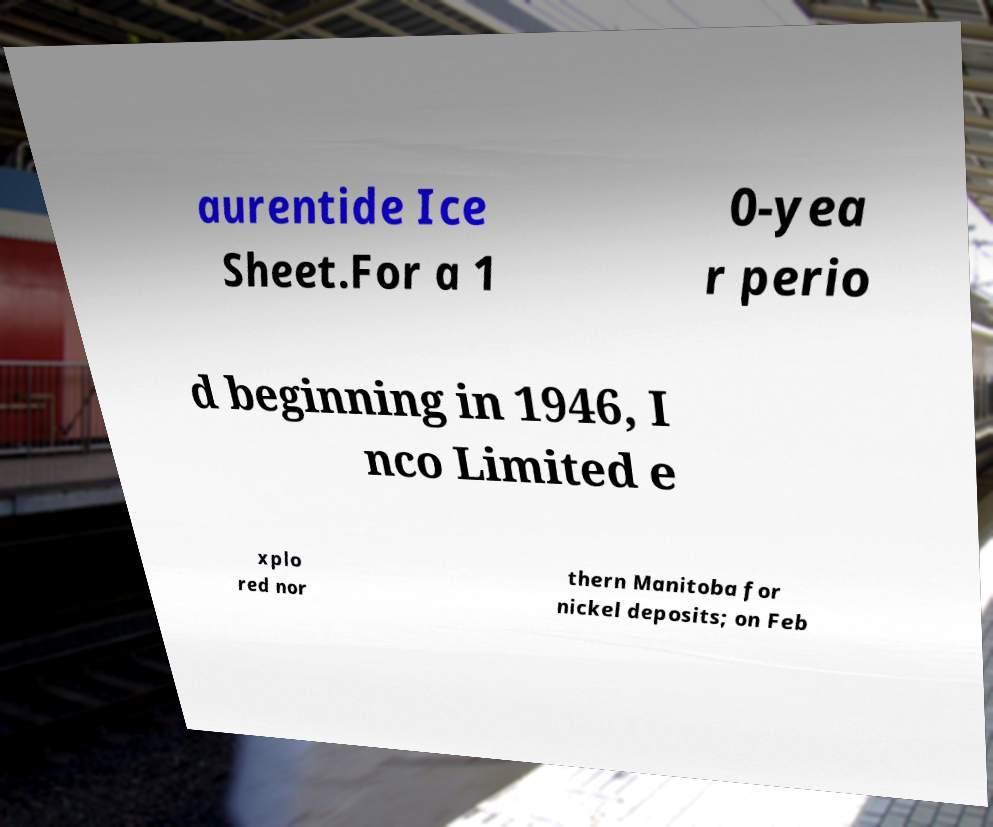I need the written content from this picture converted into text. Can you do that? aurentide Ice Sheet.For a 1 0-yea r perio d beginning in 1946, I nco Limited e xplo red nor thern Manitoba for nickel deposits; on Feb 